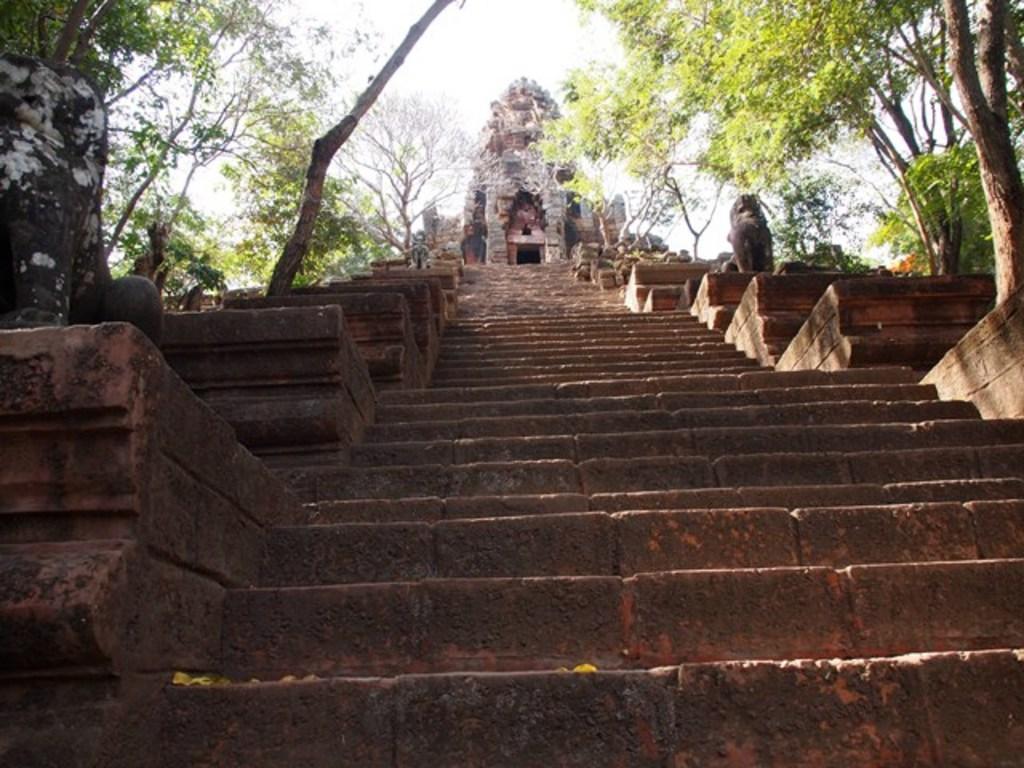In one or two sentences, can you explain what this image depicts? In the foreground of the picture there are sculpture and staircase. At the top there are trees and a temple. Sky is sunny. 